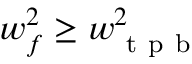Convert formula to latex. <formula><loc_0><loc_0><loc_500><loc_500>w _ { f } ^ { 2 } \geq w _ { t p b } ^ { 2 }</formula> 